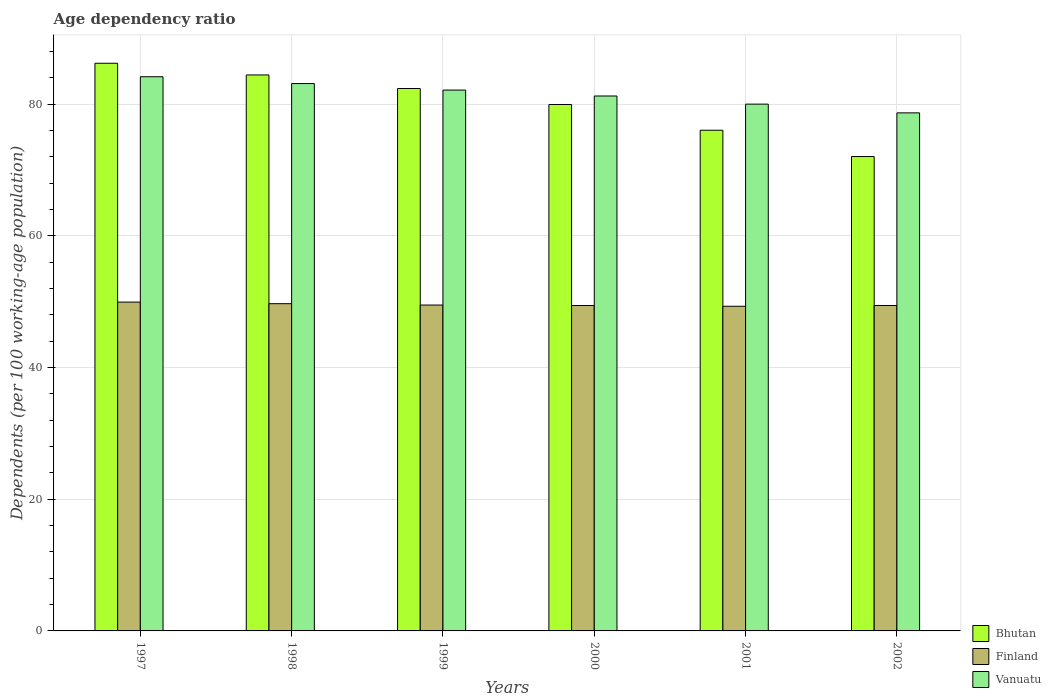Are the number of bars on each tick of the X-axis equal?
Offer a terse response. Yes. What is the label of the 3rd group of bars from the left?
Ensure brevity in your answer.  1999. What is the age dependency ratio in in Bhutan in 2000?
Keep it short and to the point. 79.94. Across all years, what is the maximum age dependency ratio in in Finland?
Keep it short and to the point. 49.93. Across all years, what is the minimum age dependency ratio in in Vanuatu?
Offer a very short reply. 78.67. What is the total age dependency ratio in in Finland in the graph?
Offer a terse response. 297.24. What is the difference between the age dependency ratio in in Finland in 1998 and that in 1999?
Give a very brief answer. 0.21. What is the difference between the age dependency ratio in in Vanuatu in 1997 and the age dependency ratio in in Bhutan in 2002?
Ensure brevity in your answer.  12.12. What is the average age dependency ratio in in Vanuatu per year?
Keep it short and to the point. 81.55. In the year 2001, what is the difference between the age dependency ratio in in Vanuatu and age dependency ratio in in Finland?
Offer a terse response. 30.69. In how many years, is the age dependency ratio in in Vanuatu greater than 20 %?
Keep it short and to the point. 6. What is the ratio of the age dependency ratio in in Vanuatu in 1999 to that in 2000?
Provide a short and direct response. 1.01. What is the difference between the highest and the second highest age dependency ratio in in Bhutan?
Keep it short and to the point. 1.78. What is the difference between the highest and the lowest age dependency ratio in in Vanuatu?
Keep it short and to the point. 5.48. In how many years, is the age dependency ratio in in Vanuatu greater than the average age dependency ratio in in Vanuatu taken over all years?
Give a very brief answer. 3. What does the 1st bar from the left in 1997 represents?
Offer a very short reply. Bhutan. What does the 3rd bar from the right in 2002 represents?
Your answer should be compact. Bhutan. Is it the case that in every year, the sum of the age dependency ratio in in Finland and age dependency ratio in in Bhutan is greater than the age dependency ratio in in Vanuatu?
Your answer should be compact. Yes. How many bars are there?
Your answer should be very brief. 18. What is the difference between two consecutive major ticks on the Y-axis?
Provide a short and direct response. 20. Does the graph contain any zero values?
Your response must be concise. No. Where does the legend appear in the graph?
Offer a terse response. Bottom right. How many legend labels are there?
Offer a very short reply. 3. How are the legend labels stacked?
Offer a terse response. Vertical. What is the title of the graph?
Give a very brief answer. Age dependency ratio. What is the label or title of the X-axis?
Provide a succinct answer. Years. What is the label or title of the Y-axis?
Give a very brief answer. Dependents (per 100 working-age population). What is the Dependents (per 100 working-age population) of Bhutan in 1997?
Provide a short and direct response. 86.2. What is the Dependents (per 100 working-age population) in Finland in 1997?
Your answer should be compact. 49.93. What is the Dependents (per 100 working-age population) in Vanuatu in 1997?
Your answer should be compact. 84.15. What is the Dependents (per 100 working-age population) in Bhutan in 1998?
Keep it short and to the point. 84.42. What is the Dependents (per 100 working-age population) in Finland in 1998?
Make the answer very short. 49.69. What is the Dependents (per 100 working-age population) of Vanuatu in 1998?
Provide a succinct answer. 83.12. What is the Dependents (per 100 working-age population) in Bhutan in 1999?
Ensure brevity in your answer.  82.37. What is the Dependents (per 100 working-age population) of Finland in 1999?
Offer a terse response. 49.49. What is the Dependents (per 100 working-age population) of Vanuatu in 1999?
Provide a succinct answer. 82.13. What is the Dependents (per 100 working-age population) of Bhutan in 2000?
Give a very brief answer. 79.94. What is the Dependents (per 100 working-age population) in Finland in 2000?
Make the answer very short. 49.41. What is the Dependents (per 100 working-age population) of Vanuatu in 2000?
Offer a very short reply. 81.23. What is the Dependents (per 100 working-age population) in Bhutan in 2001?
Provide a succinct answer. 76.03. What is the Dependents (per 100 working-age population) in Finland in 2001?
Ensure brevity in your answer.  49.3. What is the Dependents (per 100 working-age population) of Vanuatu in 2001?
Your response must be concise. 79.99. What is the Dependents (per 100 working-age population) of Bhutan in 2002?
Provide a short and direct response. 72.04. What is the Dependents (per 100 working-age population) of Finland in 2002?
Ensure brevity in your answer.  49.42. What is the Dependents (per 100 working-age population) of Vanuatu in 2002?
Give a very brief answer. 78.67. Across all years, what is the maximum Dependents (per 100 working-age population) in Bhutan?
Provide a short and direct response. 86.2. Across all years, what is the maximum Dependents (per 100 working-age population) of Finland?
Offer a terse response. 49.93. Across all years, what is the maximum Dependents (per 100 working-age population) of Vanuatu?
Your answer should be very brief. 84.15. Across all years, what is the minimum Dependents (per 100 working-age population) of Bhutan?
Your response must be concise. 72.04. Across all years, what is the minimum Dependents (per 100 working-age population) of Finland?
Offer a very short reply. 49.3. Across all years, what is the minimum Dependents (per 100 working-age population) in Vanuatu?
Provide a succinct answer. 78.67. What is the total Dependents (per 100 working-age population) in Bhutan in the graph?
Your answer should be very brief. 481. What is the total Dependents (per 100 working-age population) of Finland in the graph?
Offer a terse response. 297.24. What is the total Dependents (per 100 working-age population) in Vanuatu in the graph?
Keep it short and to the point. 489.29. What is the difference between the Dependents (per 100 working-age population) of Bhutan in 1997 and that in 1998?
Your response must be concise. 1.78. What is the difference between the Dependents (per 100 working-age population) of Finland in 1997 and that in 1998?
Ensure brevity in your answer.  0.24. What is the difference between the Dependents (per 100 working-age population) of Vanuatu in 1997 and that in 1998?
Ensure brevity in your answer.  1.04. What is the difference between the Dependents (per 100 working-age population) of Bhutan in 1997 and that in 1999?
Offer a very short reply. 3.83. What is the difference between the Dependents (per 100 working-age population) in Finland in 1997 and that in 1999?
Make the answer very short. 0.45. What is the difference between the Dependents (per 100 working-age population) in Vanuatu in 1997 and that in 1999?
Offer a terse response. 2.02. What is the difference between the Dependents (per 100 working-age population) of Bhutan in 1997 and that in 2000?
Offer a very short reply. 6.26. What is the difference between the Dependents (per 100 working-age population) in Finland in 1997 and that in 2000?
Provide a succinct answer. 0.52. What is the difference between the Dependents (per 100 working-age population) of Vanuatu in 1997 and that in 2000?
Offer a terse response. 2.92. What is the difference between the Dependents (per 100 working-age population) in Bhutan in 1997 and that in 2001?
Offer a very short reply. 10.17. What is the difference between the Dependents (per 100 working-age population) in Finland in 1997 and that in 2001?
Offer a very short reply. 0.63. What is the difference between the Dependents (per 100 working-age population) in Vanuatu in 1997 and that in 2001?
Your answer should be compact. 4.16. What is the difference between the Dependents (per 100 working-age population) of Bhutan in 1997 and that in 2002?
Make the answer very short. 14.16. What is the difference between the Dependents (per 100 working-age population) in Finland in 1997 and that in 2002?
Ensure brevity in your answer.  0.52. What is the difference between the Dependents (per 100 working-age population) of Vanuatu in 1997 and that in 2002?
Your response must be concise. 5.48. What is the difference between the Dependents (per 100 working-age population) in Bhutan in 1998 and that in 1999?
Provide a short and direct response. 2.06. What is the difference between the Dependents (per 100 working-age population) in Finland in 1998 and that in 1999?
Your answer should be compact. 0.21. What is the difference between the Dependents (per 100 working-age population) of Vanuatu in 1998 and that in 1999?
Offer a very short reply. 0.99. What is the difference between the Dependents (per 100 working-age population) of Bhutan in 1998 and that in 2000?
Your response must be concise. 4.49. What is the difference between the Dependents (per 100 working-age population) in Finland in 1998 and that in 2000?
Keep it short and to the point. 0.28. What is the difference between the Dependents (per 100 working-age population) in Vanuatu in 1998 and that in 2000?
Offer a very short reply. 1.88. What is the difference between the Dependents (per 100 working-age population) in Bhutan in 1998 and that in 2001?
Your answer should be very brief. 8.4. What is the difference between the Dependents (per 100 working-age population) of Finland in 1998 and that in 2001?
Make the answer very short. 0.39. What is the difference between the Dependents (per 100 working-age population) in Vanuatu in 1998 and that in 2001?
Make the answer very short. 3.12. What is the difference between the Dependents (per 100 working-age population) of Bhutan in 1998 and that in 2002?
Provide a succinct answer. 12.39. What is the difference between the Dependents (per 100 working-age population) of Finland in 1998 and that in 2002?
Your answer should be compact. 0.27. What is the difference between the Dependents (per 100 working-age population) in Vanuatu in 1998 and that in 2002?
Give a very brief answer. 4.45. What is the difference between the Dependents (per 100 working-age population) in Bhutan in 1999 and that in 2000?
Your answer should be compact. 2.43. What is the difference between the Dependents (per 100 working-age population) of Finland in 1999 and that in 2000?
Ensure brevity in your answer.  0.07. What is the difference between the Dependents (per 100 working-age population) of Vanuatu in 1999 and that in 2000?
Provide a short and direct response. 0.9. What is the difference between the Dependents (per 100 working-age population) of Bhutan in 1999 and that in 2001?
Ensure brevity in your answer.  6.34. What is the difference between the Dependents (per 100 working-age population) of Finland in 1999 and that in 2001?
Provide a succinct answer. 0.19. What is the difference between the Dependents (per 100 working-age population) of Vanuatu in 1999 and that in 2001?
Make the answer very short. 2.13. What is the difference between the Dependents (per 100 working-age population) of Bhutan in 1999 and that in 2002?
Give a very brief answer. 10.33. What is the difference between the Dependents (per 100 working-age population) in Finland in 1999 and that in 2002?
Offer a terse response. 0.07. What is the difference between the Dependents (per 100 working-age population) of Vanuatu in 1999 and that in 2002?
Your response must be concise. 3.46. What is the difference between the Dependents (per 100 working-age population) of Bhutan in 2000 and that in 2001?
Provide a succinct answer. 3.91. What is the difference between the Dependents (per 100 working-age population) of Finland in 2000 and that in 2001?
Ensure brevity in your answer.  0.11. What is the difference between the Dependents (per 100 working-age population) of Vanuatu in 2000 and that in 2001?
Provide a succinct answer. 1.24. What is the difference between the Dependents (per 100 working-age population) of Bhutan in 2000 and that in 2002?
Ensure brevity in your answer.  7.9. What is the difference between the Dependents (per 100 working-age population) in Finland in 2000 and that in 2002?
Your answer should be very brief. -0. What is the difference between the Dependents (per 100 working-age population) of Vanuatu in 2000 and that in 2002?
Keep it short and to the point. 2.56. What is the difference between the Dependents (per 100 working-age population) in Bhutan in 2001 and that in 2002?
Offer a very short reply. 3.99. What is the difference between the Dependents (per 100 working-age population) of Finland in 2001 and that in 2002?
Offer a terse response. -0.12. What is the difference between the Dependents (per 100 working-age population) in Vanuatu in 2001 and that in 2002?
Make the answer very short. 1.33. What is the difference between the Dependents (per 100 working-age population) of Bhutan in 1997 and the Dependents (per 100 working-age population) of Finland in 1998?
Provide a succinct answer. 36.51. What is the difference between the Dependents (per 100 working-age population) in Bhutan in 1997 and the Dependents (per 100 working-age population) in Vanuatu in 1998?
Give a very brief answer. 3.09. What is the difference between the Dependents (per 100 working-age population) in Finland in 1997 and the Dependents (per 100 working-age population) in Vanuatu in 1998?
Offer a terse response. -33.18. What is the difference between the Dependents (per 100 working-age population) of Bhutan in 1997 and the Dependents (per 100 working-age population) of Finland in 1999?
Provide a succinct answer. 36.72. What is the difference between the Dependents (per 100 working-age population) in Bhutan in 1997 and the Dependents (per 100 working-age population) in Vanuatu in 1999?
Offer a terse response. 4.07. What is the difference between the Dependents (per 100 working-age population) of Finland in 1997 and the Dependents (per 100 working-age population) of Vanuatu in 1999?
Offer a terse response. -32.2. What is the difference between the Dependents (per 100 working-age population) of Bhutan in 1997 and the Dependents (per 100 working-age population) of Finland in 2000?
Your response must be concise. 36.79. What is the difference between the Dependents (per 100 working-age population) in Bhutan in 1997 and the Dependents (per 100 working-age population) in Vanuatu in 2000?
Provide a short and direct response. 4.97. What is the difference between the Dependents (per 100 working-age population) in Finland in 1997 and the Dependents (per 100 working-age population) in Vanuatu in 2000?
Offer a terse response. -31.3. What is the difference between the Dependents (per 100 working-age population) in Bhutan in 1997 and the Dependents (per 100 working-age population) in Finland in 2001?
Offer a terse response. 36.9. What is the difference between the Dependents (per 100 working-age population) of Bhutan in 1997 and the Dependents (per 100 working-age population) of Vanuatu in 2001?
Keep it short and to the point. 6.21. What is the difference between the Dependents (per 100 working-age population) of Finland in 1997 and the Dependents (per 100 working-age population) of Vanuatu in 2001?
Offer a terse response. -30.06. What is the difference between the Dependents (per 100 working-age population) of Bhutan in 1997 and the Dependents (per 100 working-age population) of Finland in 2002?
Offer a terse response. 36.78. What is the difference between the Dependents (per 100 working-age population) in Bhutan in 1997 and the Dependents (per 100 working-age population) in Vanuatu in 2002?
Offer a terse response. 7.53. What is the difference between the Dependents (per 100 working-age population) in Finland in 1997 and the Dependents (per 100 working-age population) in Vanuatu in 2002?
Make the answer very short. -28.74. What is the difference between the Dependents (per 100 working-age population) of Bhutan in 1998 and the Dependents (per 100 working-age population) of Finland in 1999?
Make the answer very short. 34.94. What is the difference between the Dependents (per 100 working-age population) of Bhutan in 1998 and the Dependents (per 100 working-age population) of Vanuatu in 1999?
Your response must be concise. 2.3. What is the difference between the Dependents (per 100 working-age population) of Finland in 1998 and the Dependents (per 100 working-age population) of Vanuatu in 1999?
Offer a very short reply. -32.44. What is the difference between the Dependents (per 100 working-age population) in Bhutan in 1998 and the Dependents (per 100 working-age population) in Finland in 2000?
Your answer should be compact. 35.01. What is the difference between the Dependents (per 100 working-age population) in Bhutan in 1998 and the Dependents (per 100 working-age population) in Vanuatu in 2000?
Offer a very short reply. 3.19. What is the difference between the Dependents (per 100 working-age population) of Finland in 1998 and the Dependents (per 100 working-age population) of Vanuatu in 2000?
Provide a succinct answer. -31.54. What is the difference between the Dependents (per 100 working-age population) in Bhutan in 1998 and the Dependents (per 100 working-age population) in Finland in 2001?
Your answer should be compact. 35.12. What is the difference between the Dependents (per 100 working-age population) of Bhutan in 1998 and the Dependents (per 100 working-age population) of Vanuatu in 2001?
Offer a terse response. 4.43. What is the difference between the Dependents (per 100 working-age population) of Finland in 1998 and the Dependents (per 100 working-age population) of Vanuatu in 2001?
Ensure brevity in your answer.  -30.3. What is the difference between the Dependents (per 100 working-age population) in Bhutan in 1998 and the Dependents (per 100 working-age population) in Finland in 2002?
Your response must be concise. 35.01. What is the difference between the Dependents (per 100 working-age population) in Bhutan in 1998 and the Dependents (per 100 working-age population) in Vanuatu in 2002?
Offer a terse response. 5.76. What is the difference between the Dependents (per 100 working-age population) of Finland in 1998 and the Dependents (per 100 working-age population) of Vanuatu in 2002?
Your response must be concise. -28.98. What is the difference between the Dependents (per 100 working-age population) of Bhutan in 1999 and the Dependents (per 100 working-age population) of Finland in 2000?
Provide a short and direct response. 32.95. What is the difference between the Dependents (per 100 working-age population) in Bhutan in 1999 and the Dependents (per 100 working-age population) in Vanuatu in 2000?
Provide a short and direct response. 1.14. What is the difference between the Dependents (per 100 working-age population) of Finland in 1999 and the Dependents (per 100 working-age population) of Vanuatu in 2000?
Your answer should be very brief. -31.74. What is the difference between the Dependents (per 100 working-age population) of Bhutan in 1999 and the Dependents (per 100 working-age population) of Finland in 2001?
Your answer should be compact. 33.07. What is the difference between the Dependents (per 100 working-age population) in Bhutan in 1999 and the Dependents (per 100 working-age population) in Vanuatu in 2001?
Offer a terse response. 2.37. What is the difference between the Dependents (per 100 working-age population) of Finland in 1999 and the Dependents (per 100 working-age population) of Vanuatu in 2001?
Make the answer very short. -30.51. What is the difference between the Dependents (per 100 working-age population) in Bhutan in 1999 and the Dependents (per 100 working-age population) in Finland in 2002?
Your answer should be very brief. 32.95. What is the difference between the Dependents (per 100 working-age population) in Bhutan in 1999 and the Dependents (per 100 working-age population) in Vanuatu in 2002?
Offer a terse response. 3.7. What is the difference between the Dependents (per 100 working-age population) in Finland in 1999 and the Dependents (per 100 working-age population) in Vanuatu in 2002?
Offer a terse response. -29.18. What is the difference between the Dependents (per 100 working-age population) in Bhutan in 2000 and the Dependents (per 100 working-age population) in Finland in 2001?
Your response must be concise. 30.64. What is the difference between the Dependents (per 100 working-age population) of Bhutan in 2000 and the Dependents (per 100 working-age population) of Vanuatu in 2001?
Your answer should be compact. -0.06. What is the difference between the Dependents (per 100 working-age population) in Finland in 2000 and the Dependents (per 100 working-age population) in Vanuatu in 2001?
Your response must be concise. -30.58. What is the difference between the Dependents (per 100 working-age population) of Bhutan in 2000 and the Dependents (per 100 working-age population) of Finland in 2002?
Provide a short and direct response. 30.52. What is the difference between the Dependents (per 100 working-age population) of Bhutan in 2000 and the Dependents (per 100 working-age population) of Vanuatu in 2002?
Your answer should be compact. 1.27. What is the difference between the Dependents (per 100 working-age population) of Finland in 2000 and the Dependents (per 100 working-age population) of Vanuatu in 2002?
Your response must be concise. -29.26. What is the difference between the Dependents (per 100 working-age population) of Bhutan in 2001 and the Dependents (per 100 working-age population) of Finland in 2002?
Your answer should be very brief. 26.61. What is the difference between the Dependents (per 100 working-age population) of Bhutan in 2001 and the Dependents (per 100 working-age population) of Vanuatu in 2002?
Make the answer very short. -2.64. What is the difference between the Dependents (per 100 working-age population) of Finland in 2001 and the Dependents (per 100 working-age population) of Vanuatu in 2002?
Your response must be concise. -29.37. What is the average Dependents (per 100 working-age population) in Bhutan per year?
Your answer should be compact. 80.17. What is the average Dependents (per 100 working-age population) in Finland per year?
Give a very brief answer. 49.54. What is the average Dependents (per 100 working-age population) of Vanuatu per year?
Provide a succinct answer. 81.55. In the year 1997, what is the difference between the Dependents (per 100 working-age population) in Bhutan and Dependents (per 100 working-age population) in Finland?
Offer a terse response. 36.27. In the year 1997, what is the difference between the Dependents (per 100 working-age population) of Bhutan and Dependents (per 100 working-age population) of Vanuatu?
Ensure brevity in your answer.  2.05. In the year 1997, what is the difference between the Dependents (per 100 working-age population) in Finland and Dependents (per 100 working-age population) in Vanuatu?
Give a very brief answer. -34.22. In the year 1998, what is the difference between the Dependents (per 100 working-age population) of Bhutan and Dependents (per 100 working-age population) of Finland?
Offer a terse response. 34.73. In the year 1998, what is the difference between the Dependents (per 100 working-age population) in Bhutan and Dependents (per 100 working-age population) in Vanuatu?
Provide a short and direct response. 1.31. In the year 1998, what is the difference between the Dependents (per 100 working-age population) in Finland and Dependents (per 100 working-age population) in Vanuatu?
Offer a terse response. -33.42. In the year 1999, what is the difference between the Dependents (per 100 working-age population) of Bhutan and Dependents (per 100 working-age population) of Finland?
Offer a terse response. 32.88. In the year 1999, what is the difference between the Dependents (per 100 working-age population) of Bhutan and Dependents (per 100 working-age population) of Vanuatu?
Give a very brief answer. 0.24. In the year 1999, what is the difference between the Dependents (per 100 working-age population) of Finland and Dependents (per 100 working-age population) of Vanuatu?
Offer a very short reply. -32.64. In the year 2000, what is the difference between the Dependents (per 100 working-age population) in Bhutan and Dependents (per 100 working-age population) in Finland?
Make the answer very short. 30.53. In the year 2000, what is the difference between the Dependents (per 100 working-age population) of Bhutan and Dependents (per 100 working-age population) of Vanuatu?
Ensure brevity in your answer.  -1.29. In the year 2000, what is the difference between the Dependents (per 100 working-age population) in Finland and Dependents (per 100 working-age population) in Vanuatu?
Ensure brevity in your answer.  -31.82. In the year 2001, what is the difference between the Dependents (per 100 working-age population) in Bhutan and Dependents (per 100 working-age population) in Finland?
Your answer should be very brief. 26.73. In the year 2001, what is the difference between the Dependents (per 100 working-age population) in Bhutan and Dependents (per 100 working-age population) in Vanuatu?
Make the answer very short. -3.97. In the year 2001, what is the difference between the Dependents (per 100 working-age population) in Finland and Dependents (per 100 working-age population) in Vanuatu?
Offer a terse response. -30.7. In the year 2002, what is the difference between the Dependents (per 100 working-age population) of Bhutan and Dependents (per 100 working-age population) of Finland?
Give a very brief answer. 22.62. In the year 2002, what is the difference between the Dependents (per 100 working-age population) in Bhutan and Dependents (per 100 working-age population) in Vanuatu?
Keep it short and to the point. -6.63. In the year 2002, what is the difference between the Dependents (per 100 working-age population) in Finland and Dependents (per 100 working-age population) in Vanuatu?
Your answer should be very brief. -29.25. What is the ratio of the Dependents (per 100 working-age population) in Bhutan in 1997 to that in 1998?
Your answer should be compact. 1.02. What is the ratio of the Dependents (per 100 working-age population) of Vanuatu in 1997 to that in 1998?
Provide a succinct answer. 1.01. What is the ratio of the Dependents (per 100 working-age population) in Bhutan in 1997 to that in 1999?
Give a very brief answer. 1.05. What is the ratio of the Dependents (per 100 working-age population) in Finland in 1997 to that in 1999?
Make the answer very short. 1.01. What is the ratio of the Dependents (per 100 working-age population) of Vanuatu in 1997 to that in 1999?
Ensure brevity in your answer.  1.02. What is the ratio of the Dependents (per 100 working-age population) of Bhutan in 1997 to that in 2000?
Your response must be concise. 1.08. What is the ratio of the Dependents (per 100 working-age population) of Finland in 1997 to that in 2000?
Keep it short and to the point. 1.01. What is the ratio of the Dependents (per 100 working-age population) in Vanuatu in 1997 to that in 2000?
Keep it short and to the point. 1.04. What is the ratio of the Dependents (per 100 working-age population) in Bhutan in 1997 to that in 2001?
Your answer should be compact. 1.13. What is the ratio of the Dependents (per 100 working-age population) in Finland in 1997 to that in 2001?
Offer a terse response. 1.01. What is the ratio of the Dependents (per 100 working-age population) of Vanuatu in 1997 to that in 2001?
Offer a terse response. 1.05. What is the ratio of the Dependents (per 100 working-age population) in Bhutan in 1997 to that in 2002?
Your response must be concise. 1.2. What is the ratio of the Dependents (per 100 working-age population) of Finland in 1997 to that in 2002?
Ensure brevity in your answer.  1.01. What is the ratio of the Dependents (per 100 working-age population) of Vanuatu in 1997 to that in 2002?
Ensure brevity in your answer.  1.07. What is the ratio of the Dependents (per 100 working-age population) of Bhutan in 1998 to that in 2000?
Provide a short and direct response. 1.06. What is the ratio of the Dependents (per 100 working-age population) of Finland in 1998 to that in 2000?
Keep it short and to the point. 1.01. What is the ratio of the Dependents (per 100 working-age population) in Vanuatu in 1998 to that in 2000?
Your answer should be very brief. 1.02. What is the ratio of the Dependents (per 100 working-age population) of Bhutan in 1998 to that in 2001?
Provide a succinct answer. 1.11. What is the ratio of the Dependents (per 100 working-age population) of Finland in 1998 to that in 2001?
Ensure brevity in your answer.  1.01. What is the ratio of the Dependents (per 100 working-age population) of Vanuatu in 1998 to that in 2001?
Provide a succinct answer. 1.04. What is the ratio of the Dependents (per 100 working-age population) in Bhutan in 1998 to that in 2002?
Ensure brevity in your answer.  1.17. What is the ratio of the Dependents (per 100 working-age population) of Finland in 1998 to that in 2002?
Offer a terse response. 1.01. What is the ratio of the Dependents (per 100 working-age population) of Vanuatu in 1998 to that in 2002?
Offer a terse response. 1.06. What is the ratio of the Dependents (per 100 working-age population) in Bhutan in 1999 to that in 2000?
Provide a short and direct response. 1.03. What is the ratio of the Dependents (per 100 working-age population) of Vanuatu in 1999 to that in 2000?
Offer a terse response. 1.01. What is the ratio of the Dependents (per 100 working-age population) in Bhutan in 1999 to that in 2001?
Give a very brief answer. 1.08. What is the ratio of the Dependents (per 100 working-age population) of Vanuatu in 1999 to that in 2001?
Ensure brevity in your answer.  1.03. What is the ratio of the Dependents (per 100 working-age population) of Bhutan in 1999 to that in 2002?
Provide a succinct answer. 1.14. What is the ratio of the Dependents (per 100 working-age population) in Vanuatu in 1999 to that in 2002?
Your answer should be very brief. 1.04. What is the ratio of the Dependents (per 100 working-age population) of Bhutan in 2000 to that in 2001?
Provide a succinct answer. 1.05. What is the ratio of the Dependents (per 100 working-age population) in Finland in 2000 to that in 2001?
Provide a short and direct response. 1. What is the ratio of the Dependents (per 100 working-age population) in Vanuatu in 2000 to that in 2001?
Provide a short and direct response. 1.02. What is the ratio of the Dependents (per 100 working-age population) in Bhutan in 2000 to that in 2002?
Make the answer very short. 1.11. What is the ratio of the Dependents (per 100 working-age population) of Finland in 2000 to that in 2002?
Your answer should be very brief. 1. What is the ratio of the Dependents (per 100 working-age population) in Vanuatu in 2000 to that in 2002?
Your answer should be compact. 1.03. What is the ratio of the Dependents (per 100 working-age population) in Bhutan in 2001 to that in 2002?
Your response must be concise. 1.06. What is the ratio of the Dependents (per 100 working-age population) in Vanuatu in 2001 to that in 2002?
Your response must be concise. 1.02. What is the difference between the highest and the second highest Dependents (per 100 working-age population) of Bhutan?
Offer a very short reply. 1.78. What is the difference between the highest and the second highest Dependents (per 100 working-age population) of Finland?
Your answer should be compact. 0.24. What is the difference between the highest and the second highest Dependents (per 100 working-age population) in Vanuatu?
Make the answer very short. 1.04. What is the difference between the highest and the lowest Dependents (per 100 working-age population) in Bhutan?
Ensure brevity in your answer.  14.16. What is the difference between the highest and the lowest Dependents (per 100 working-age population) of Finland?
Offer a terse response. 0.63. What is the difference between the highest and the lowest Dependents (per 100 working-age population) in Vanuatu?
Keep it short and to the point. 5.48. 